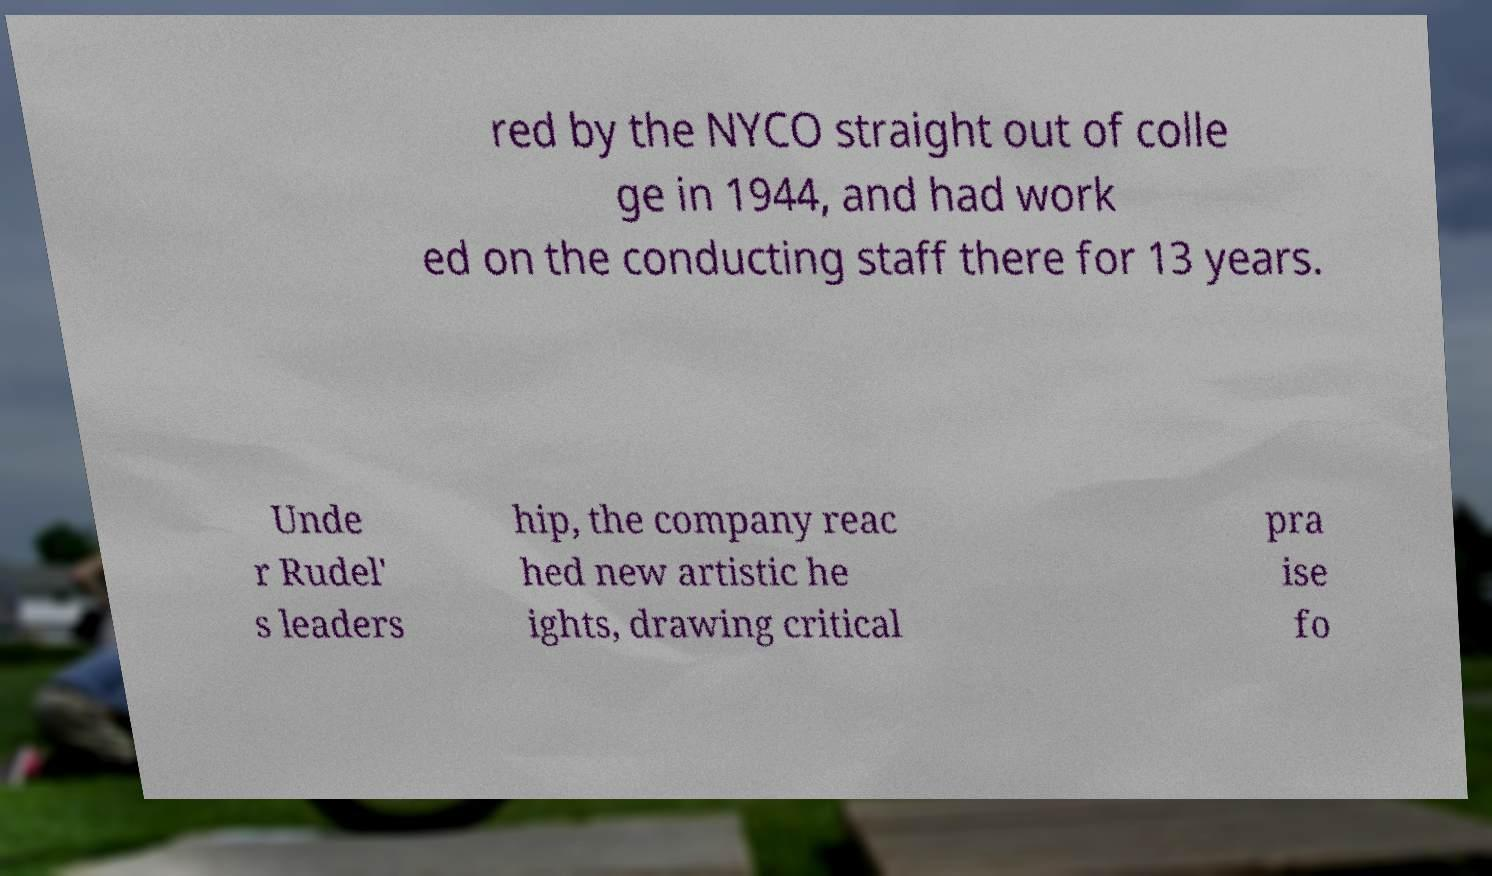Could you extract and type out the text from this image? red by the NYCO straight out of colle ge in 1944, and had work ed on the conducting staff there for 13 years. Unde r Rudel' s leaders hip, the company reac hed new artistic he ights, drawing critical pra ise fo 